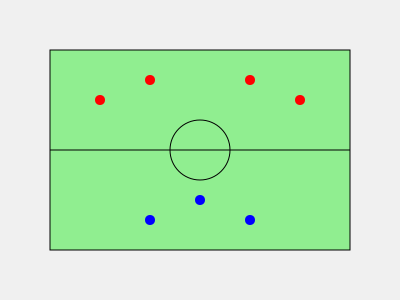In the lacrosse field diagram, red dots represent offensive players and blue dots represent defensive players. What formation does the offensive team appear to be using? To identify the offensive formation, let's analyze the positions of the red dots (offensive players) step-by-step:

1. There are 4 red dots on the diagram, representing offensive players.
2. The dots are positioned in a semicircle or arc shape at the top half of the field.
3. This formation has two players closer to the sidelines (at x-coordinates 100 and 300) and two players more centrally positioned (at x-coordinates 150 and 250).
4. The arrangement creates a wide, spread-out formation across the field.
5. In lacrosse, this type of formation is commonly known as a "1-3" or "Arc" formation.
6. The "1-3" name comes from having one player at the top center (not shown in this diagram) and three players spread out in an arc below.
7. This formation is often used to create space and passing lanes, allowing for quick ball movement and potential scoring opportunities.

Given the positioning of the offensive players in a wide, arcing formation, the most appropriate term for this setup is the "Arc" formation.
Answer: Arc formation 